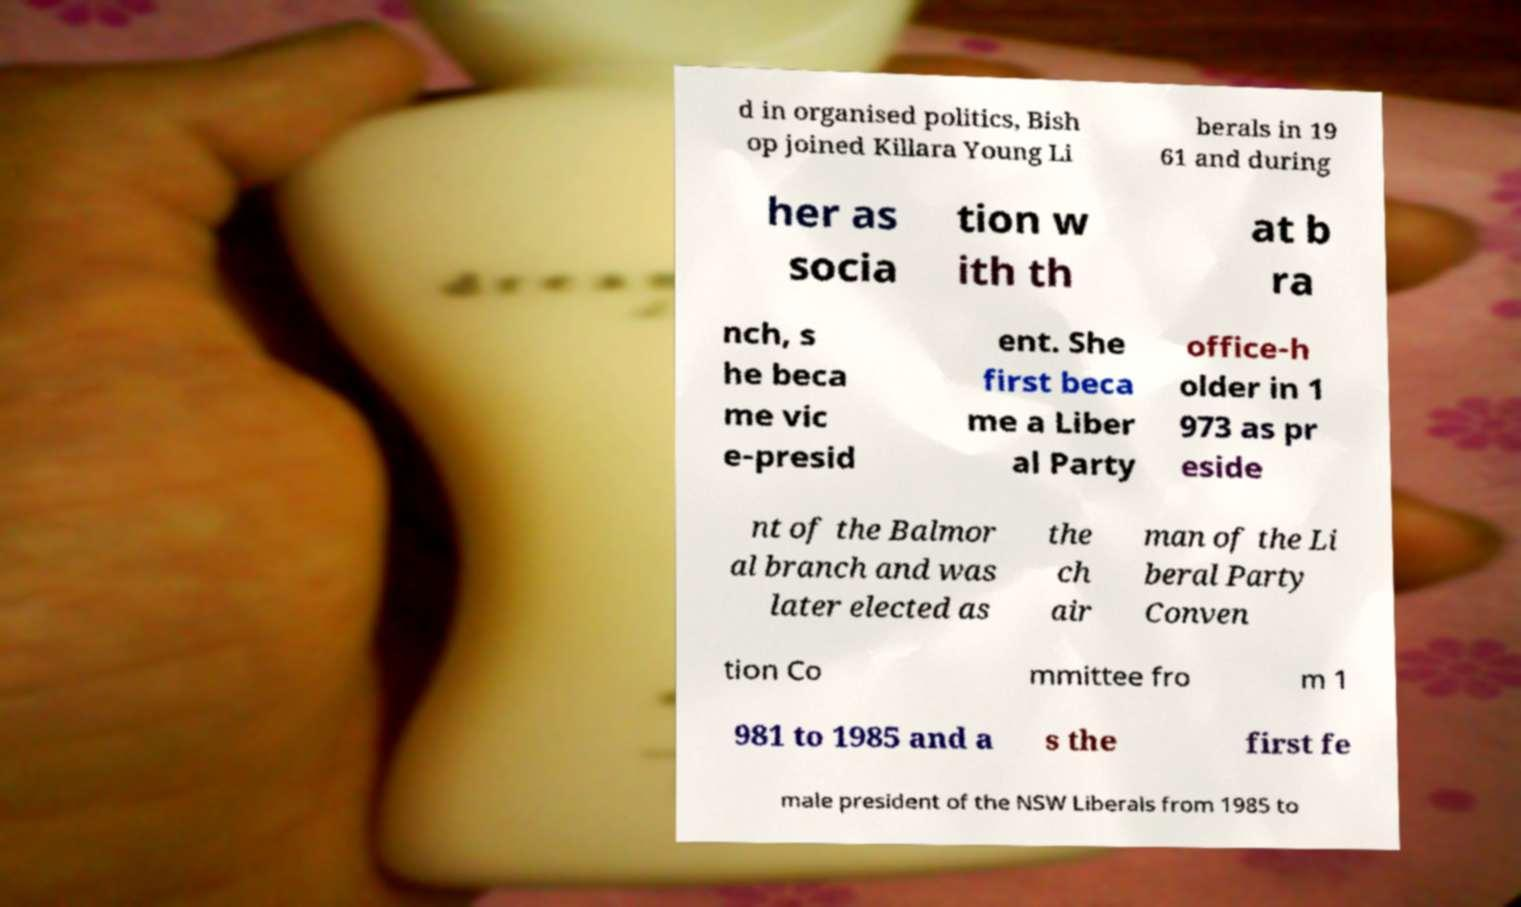There's text embedded in this image that I need extracted. Can you transcribe it verbatim? d in organised politics, Bish op joined Killara Young Li berals in 19 61 and during her as socia tion w ith th at b ra nch, s he beca me vic e-presid ent. She first beca me a Liber al Party office-h older in 1 973 as pr eside nt of the Balmor al branch and was later elected as the ch air man of the Li beral Party Conven tion Co mmittee fro m 1 981 to 1985 and a s the first fe male president of the NSW Liberals from 1985 to 